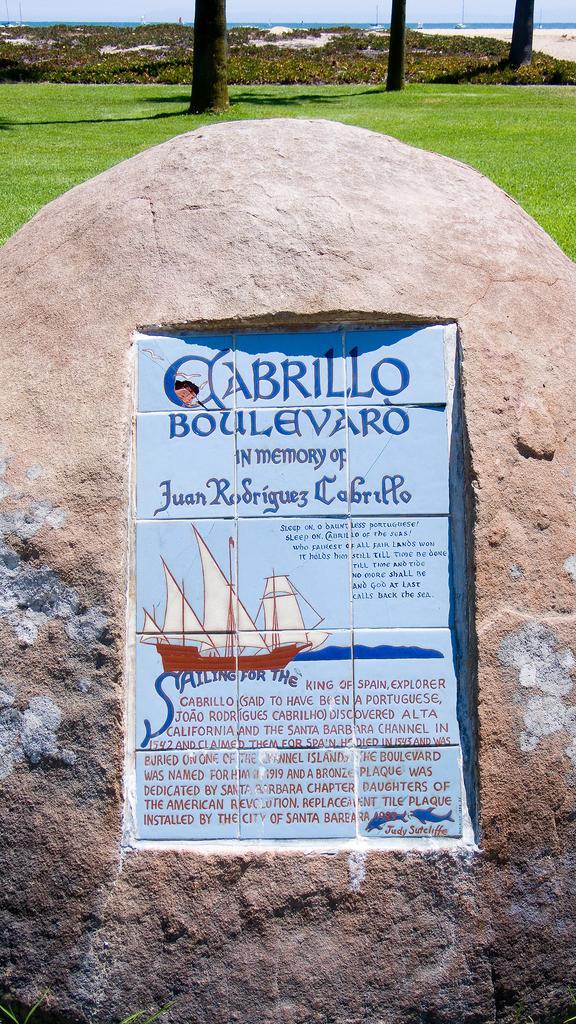Describe this image in one or two sentences. In this image we can see lay stone, grass, trees, water and sky. 